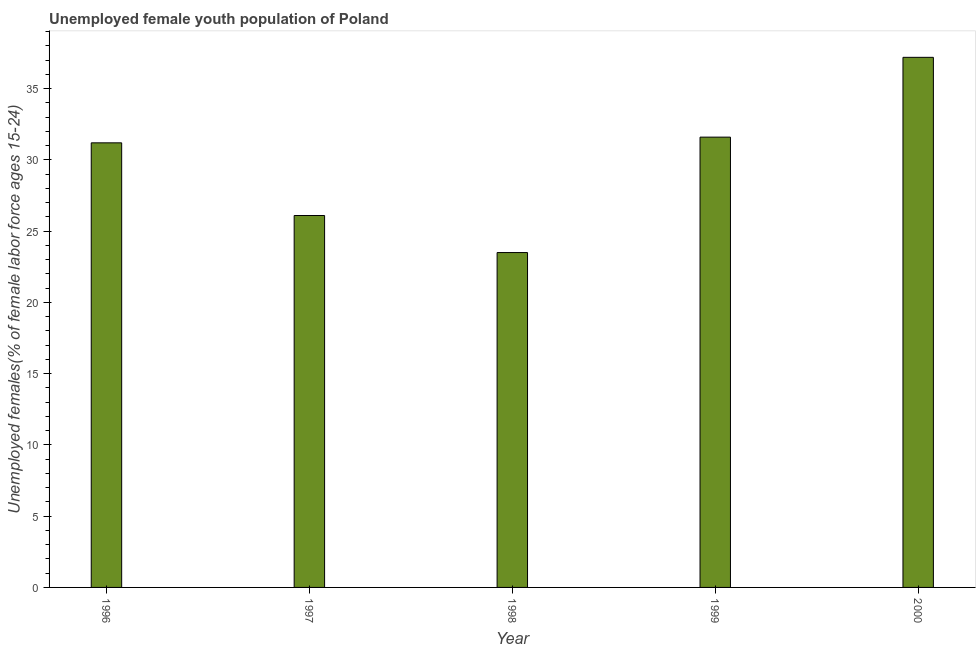What is the title of the graph?
Your response must be concise. Unemployed female youth population of Poland. What is the label or title of the Y-axis?
Provide a succinct answer. Unemployed females(% of female labor force ages 15-24). What is the unemployed female youth in 1996?
Offer a terse response. 31.2. Across all years, what is the maximum unemployed female youth?
Offer a terse response. 37.2. In which year was the unemployed female youth maximum?
Provide a short and direct response. 2000. What is the sum of the unemployed female youth?
Offer a terse response. 149.6. What is the difference between the unemployed female youth in 1996 and 1998?
Your answer should be compact. 7.7. What is the average unemployed female youth per year?
Provide a succinct answer. 29.92. What is the median unemployed female youth?
Your response must be concise. 31.2. In how many years, is the unemployed female youth greater than 20 %?
Your answer should be very brief. 5. What is the ratio of the unemployed female youth in 1997 to that in 1998?
Offer a terse response. 1.11. Is the unemployed female youth in 1996 less than that in 1999?
Your answer should be compact. Yes. What is the difference between the highest and the second highest unemployed female youth?
Keep it short and to the point. 5.6. How many bars are there?
Offer a terse response. 5. What is the difference between two consecutive major ticks on the Y-axis?
Provide a short and direct response. 5. What is the Unemployed females(% of female labor force ages 15-24) of 1996?
Your answer should be compact. 31.2. What is the Unemployed females(% of female labor force ages 15-24) in 1997?
Your answer should be compact. 26.1. What is the Unemployed females(% of female labor force ages 15-24) of 1999?
Provide a short and direct response. 31.6. What is the Unemployed females(% of female labor force ages 15-24) of 2000?
Your answer should be compact. 37.2. What is the difference between the Unemployed females(% of female labor force ages 15-24) in 1996 and 1997?
Offer a very short reply. 5.1. What is the difference between the Unemployed females(% of female labor force ages 15-24) in 1996 and 1998?
Make the answer very short. 7.7. What is the difference between the Unemployed females(% of female labor force ages 15-24) in 1997 and 1999?
Offer a very short reply. -5.5. What is the difference between the Unemployed females(% of female labor force ages 15-24) in 1998 and 2000?
Keep it short and to the point. -13.7. What is the ratio of the Unemployed females(% of female labor force ages 15-24) in 1996 to that in 1997?
Your response must be concise. 1.2. What is the ratio of the Unemployed females(% of female labor force ages 15-24) in 1996 to that in 1998?
Offer a very short reply. 1.33. What is the ratio of the Unemployed females(% of female labor force ages 15-24) in 1996 to that in 1999?
Your answer should be compact. 0.99. What is the ratio of the Unemployed females(% of female labor force ages 15-24) in 1996 to that in 2000?
Provide a short and direct response. 0.84. What is the ratio of the Unemployed females(% of female labor force ages 15-24) in 1997 to that in 1998?
Ensure brevity in your answer.  1.11. What is the ratio of the Unemployed females(% of female labor force ages 15-24) in 1997 to that in 1999?
Provide a succinct answer. 0.83. What is the ratio of the Unemployed females(% of female labor force ages 15-24) in 1997 to that in 2000?
Your answer should be very brief. 0.7. What is the ratio of the Unemployed females(% of female labor force ages 15-24) in 1998 to that in 1999?
Keep it short and to the point. 0.74. What is the ratio of the Unemployed females(% of female labor force ages 15-24) in 1998 to that in 2000?
Ensure brevity in your answer.  0.63. What is the ratio of the Unemployed females(% of female labor force ages 15-24) in 1999 to that in 2000?
Your answer should be very brief. 0.85. 